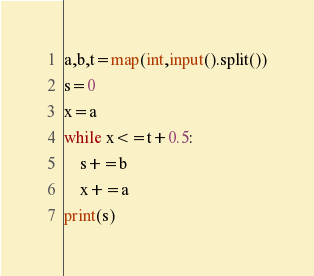<code> <loc_0><loc_0><loc_500><loc_500><_Python_>a,b,t=map(int,input().split())
s=0
x=a
while x<=t+0.5:
    s+=b
    x+=a
print(s)
</code> 